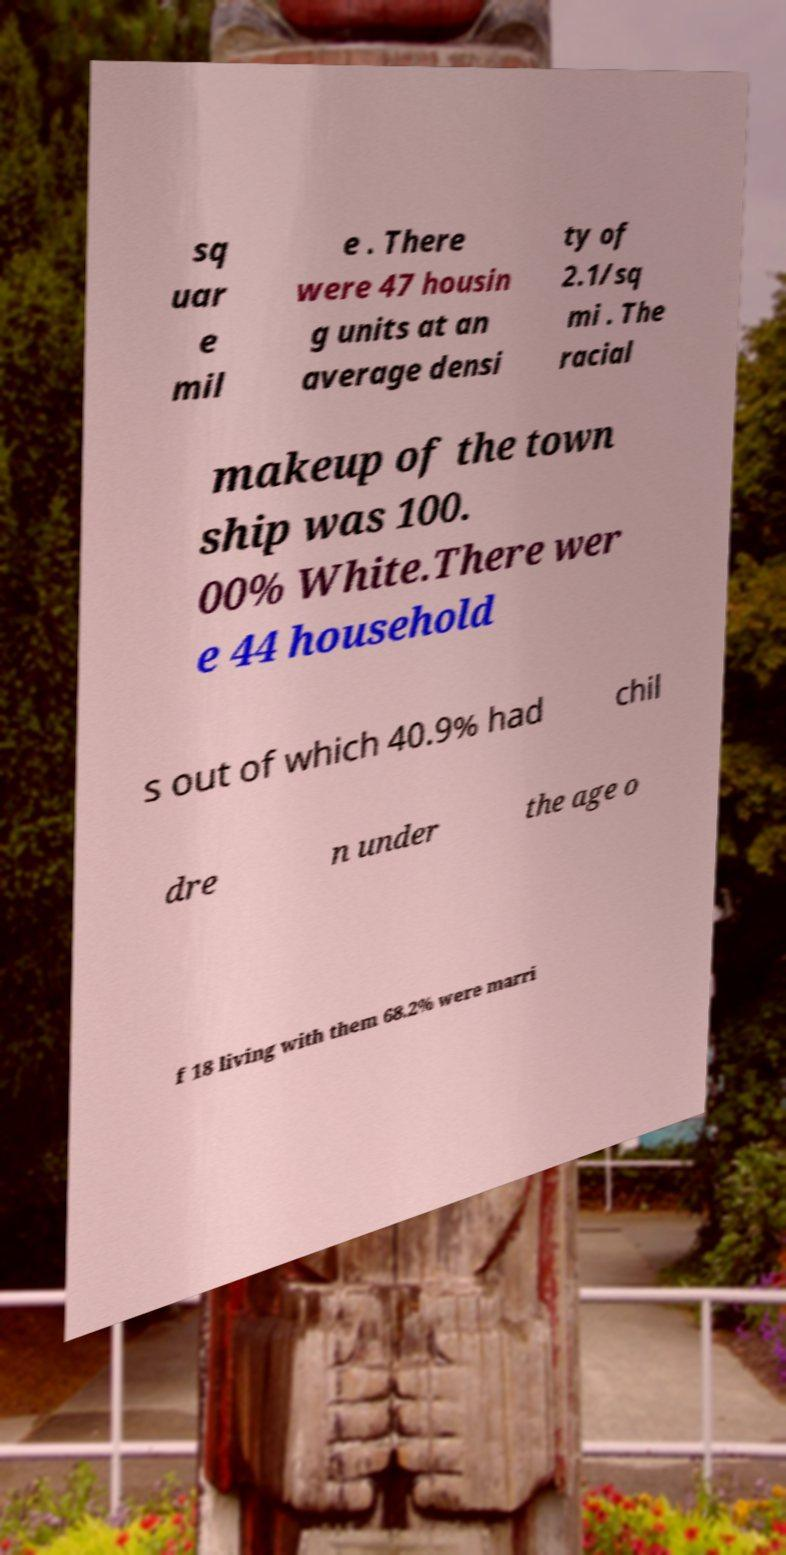I need the written content from this picture converted into text. Can you do that? sq uar e mil e . There were 47 housin g units at an average densi ty of 2.1/sq mi . The racial makeup of the town ship was 100. 00% White.There wer e 44 household s out of which 40.9% had chil dre n under the age o f 18 living with them 68.2% were marri 